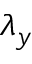Convert formula to latex. <formula><loc_0><loc_0><loc_500><loc_500>\lambda _ { y }</formula> 